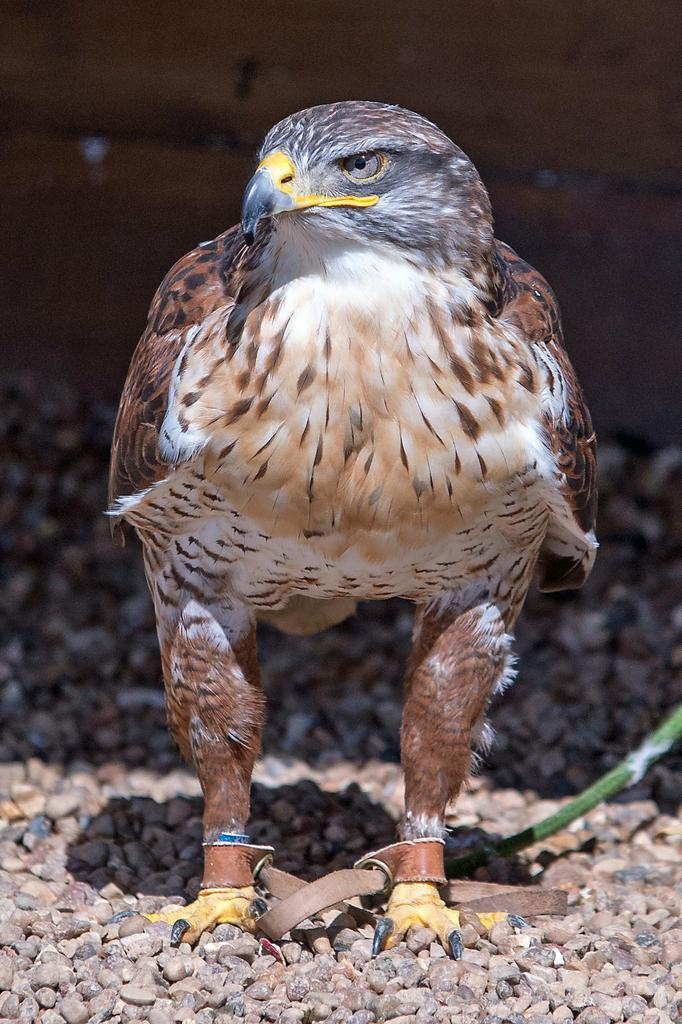What type of animal is present in the image? There is a bird in the image. Can you describe any unique features of the bird? The bird has a belt tied to its legs. What else can be seen in the image besides the bird? A: There are stones in the image. How would you describe the background of the image? The background of the image is blurred. What type of plastic item is being used by the bird in the image? There is no plastic item present in the image. Can you describe the bird's interaction with the mitten in the image? There is no mitten present in the image. 